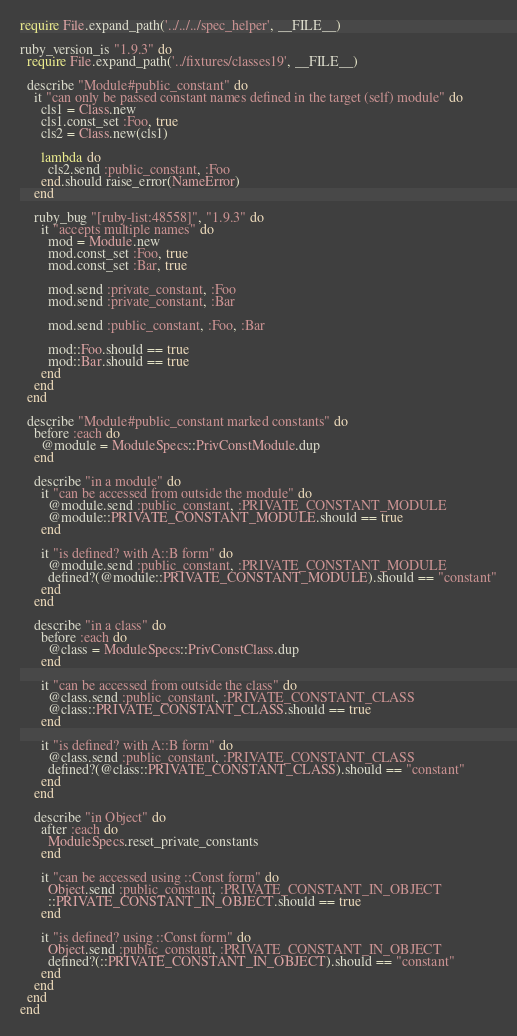Convert code to text. <code><loc_0><loc_0><loc_500><loc_500><_Ruby_>require File.expand_path('../../../spec_helper', __FILE__)

ruby_version_is "1.9.3" do
  require File.expand_path('../fixtures/classes19', __FILE__)
  
  describe "Module#public_constant" do
    it "can only be passed constant names defined in the target (self) module" do
      cls1 = Class.new
      cls1.const_set :Foo, true
      cls2 = Class.new(cls1)
      
      lambda do
        cls2.send :public_constant, :Foo
      end.should raise_error(NameError)
    end
    
    ruby_bug "[ruby-list:48558]", "1.9.3" do
      it "accepts multiple names" do
        mod = Module.new
        mod.const_set :Foo, true
        mod.const_set :Bar, true
        
        mod.send :private_constant, :Foo
        mod.send :private_constant, :Bar
        
        mod.send :public_constant, :Foo, :Bar
        
        mod::Foo.should == true
        mod::Bar.should == true
      end
    end
  end
  
  describe "Module#public_constant marked constants" do
    before :each do
      @module = ModuleSpecs::PrivConstModule.dup
    end
    
    describe "in a module" do
      it "can be accessed from outside the module" do
        @module.send :public_constant, :PRIVATE_CONSTANT_MODULE
        @module::PRIVATE_CONSTANT_MODULE.should == true
      end
      
      it "is defined? with A::B form" do
        @module.send :public_constant, :PRIVATE_CONSTANT_MODULE
        defined?(@module::PRIVATE_CONSTANT_MODULE).should == "constant"
      end
    end
    
    describe "in a class" do
      before :each do
        @class = ModuleSpecs::PrivConstClass.dup
      end
      
      it "can be accessed from outside the class" do
        @class.send :public_constant, :PRIVATE_CONSTANT_CLASS
        @class::PRIVATE_CONSTANT_CLASS.should == true
      end
      
      it "is defined? with A::B form" do
        @class.send :public_constant, :PRIVATE_CONSTANT_CLASS
        defined?(@class::PRIVATE_CONSTANT_CLASS).should == "constant"
      end
    end
    
    describe "in Object" do
      after :each do
        ModuleSpecs.reset_private_constants
      end
      
      it "can be accessed using ::Const form" do
        Object.send :public_constant, :PRIVATE_CONSTANT_IN_OBJECT
        ::PRIVATE_CONSTANT_IN_OBJECT.should == true
      end
      
      it "is defined? using ::Const form" do
        Object.send :public_constant, :PRIVATE_CONSTANT_IN_OBJECT
        defined?(::PRIVATE_CONSTANT_IN_OBJECT).should == "constant"
      end
    end
  end
end
</code> 